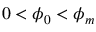Convert formula to latex. <formula><loc_0><loc_0><loc_500><loc_500>0 < \phi _ { 0 } < \phi _ { m }</formula> 